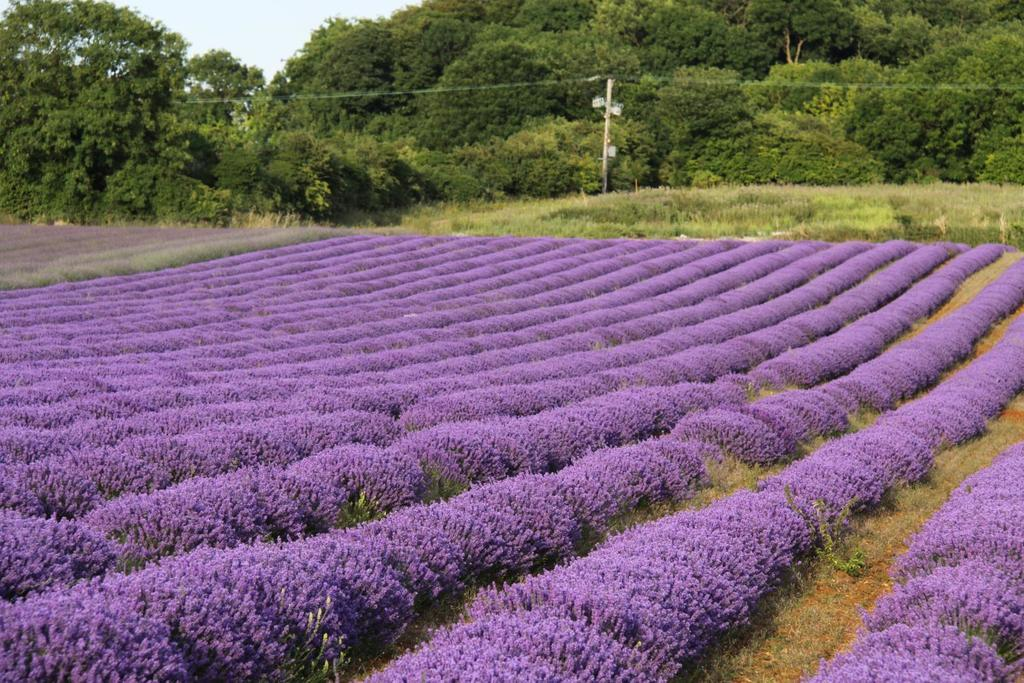What is the main subject of the image? The main subject of the image is a flower field. What can be seen in the background of the image? There are trees and a current pole in the background of the image. How many sails are visible on the current pole in the image? There are no sails visible on the current pole in the image, as it is not a sailboat or a structure that typically has sails. 